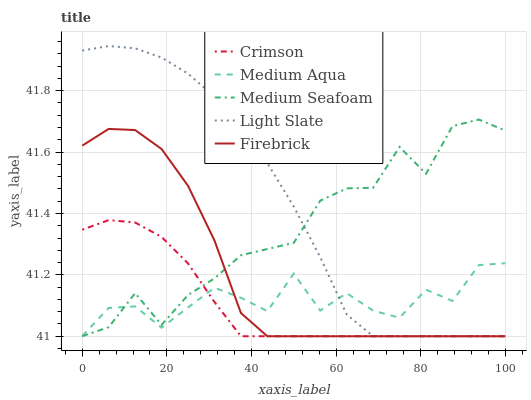Does Crimson have the minimum area under the curve?
Answer yes or no. Yes. Does Light Slate have the maximum area under the curve?
Answer yes or no. Yes. Does Firebrick have the minimum area under the curve?
Answer yes or no. No. Does Firebrick have the maximum area under the curve?
Answer yes or no. No. Is Crimson the smoothest?
Answer yes or no. Yes. Is Medium Seafoam the roughest?
Answer yes or no. Yes. Is Light Slate the smoothest?
Answer yes or no. No. Is Light Slate the roughest?
Answer yes or no. No. Does Medium Aqua have the lowest value?
Answer yes or no. No. Does Firebrick have the highest value?
Answer yes or no. No. 